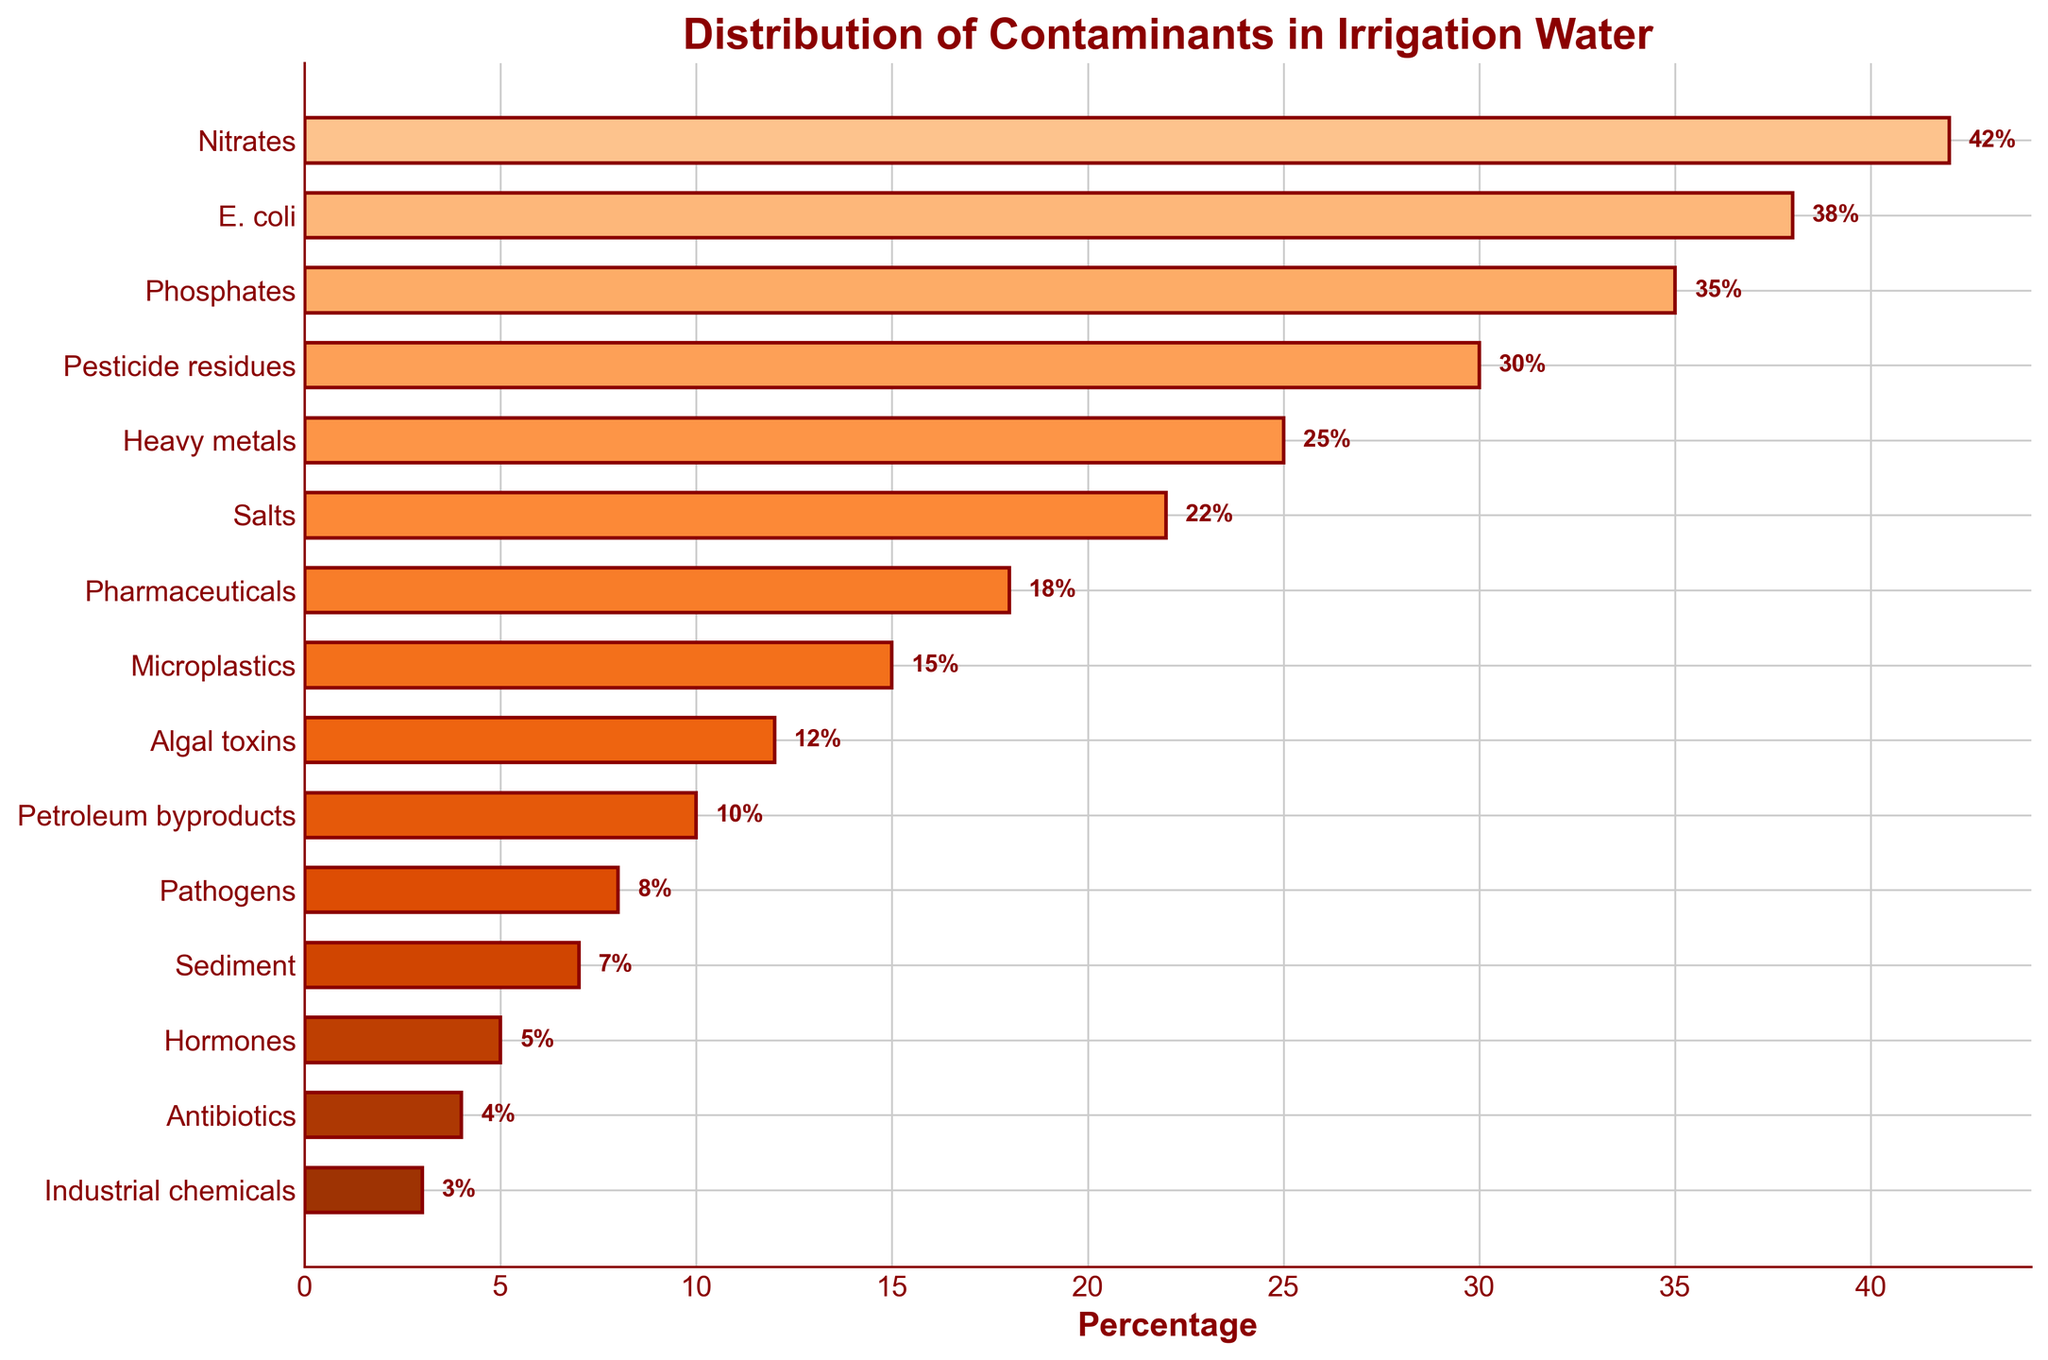What contaminant has the highest percentage found in the irrigation water? Look for the bar with the greatest length and value on the x-axis. The bar for Nitrates has the highest value at 42%.
Answer: Nitrates Which contaminants have a percentage over 30%? Identify the bars that extend past the 30% mark on the x-axis. These are Nitrates (42%), E. coli (38%), Phosphates (35%), and Pesticide residues (30%).
Answer: Nitrates, E. coli, Phosphates, Pesticide residues How much higher is the percentage of Nitrates compared to Heavy metals? Subtract the percentage of Heavy metals (25%) from that of Nitrates (42%). 42% - 25% = 17%.
Answer: 17% Arrange the top three contaminants in descending order of their percentage. Identify the top three contaminants by their x-axis values: Nitrates (42%), E. coli (38%), and Phosphates (35%). Arrange them from highest to lowest: Nitrates, E. coli, Phosphates.
Answer: Nitrates, E. coli, Phosphates What is the cumulative percentage of the four least common contaminants? Add the percentages of the four least common contaminants: Hormones (5%), Antibiotics (4%), Industrial chemicals (3%), and Pathogens (8%). 5% + 4% + 3% + 8% = 20%.
Answer: 20% Is the percentage of Salts greater than the percentage of Heavy metals? Compare the endpoints of the bars for Salts (22%) and Heavy metals (25%). Salts is less than Heavy metals.
Answer: No Which contaminant has a percentage closest to but less than 10%? Look at the bars just below the 10% mark. Petroleum byproducts are at 10%, and Algal toxins are at 12%, so the closest and less than these is Pathogens at 8%.
Answer: Pathogens What is the difference in percentage between Pharmaceuticals and Microplastics? Subtract the percentage of Microplastics (15%) from that of Pharmaceuticals (18%). 18% - 15% = 3%.
Answer: 3% What is the average percentage of the top five contaminants? Sum the percentages of the top five contaminants: Nitrates (42%), E. coli (38%), Phosphates (35%), Pesticide residues (30%), Heavy metals (25%). Then divide by 5. (42 + 38 + 35 + 30 + 25) / 5 = 34%.
Answer: 34% 